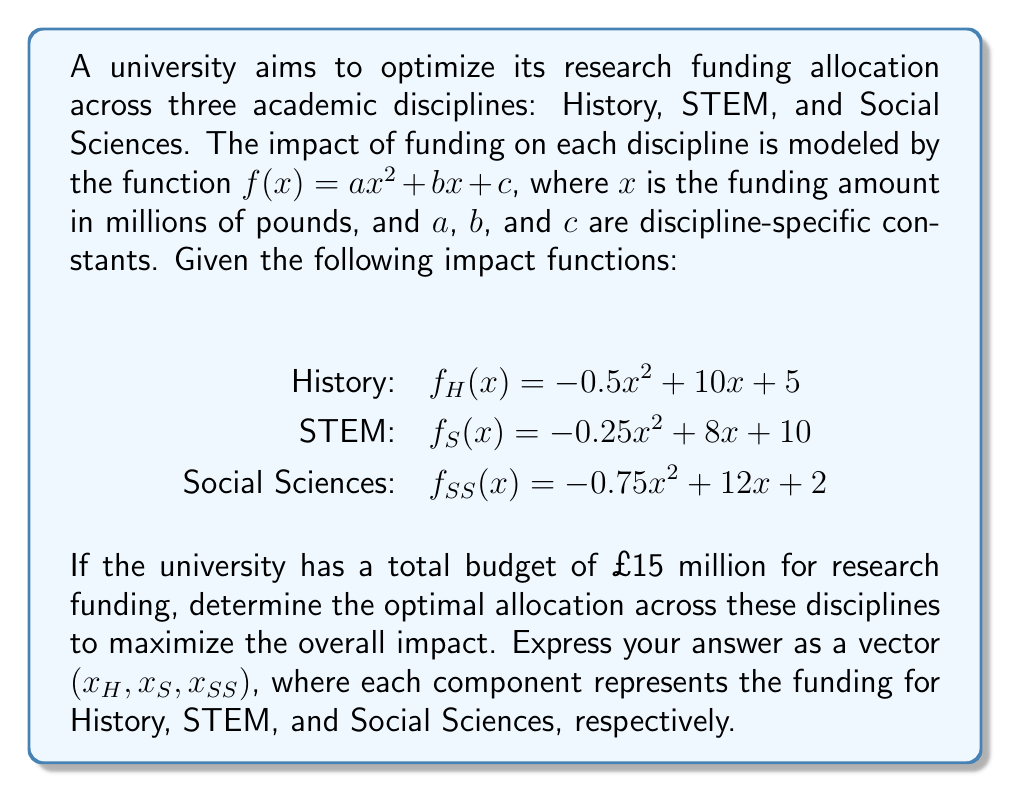Provide a solution to this math problem. To solve this optimization problem, we'll use the method of Lagrange multipliers:

1) Let's define our objective function as the sum of the impact functions:
   $$F(x_H, x_S, x_{SS}) = f_H(x_H) + f_S(x_S) + f_{SS}(x_{SS})$$

2) Our constraint is:
   $$g(x_H, x_S, x_{SS}) = x_H + x_S + x_{SS} - 15 = 0$$

3) We form the Lagrangian:
   $$L(x_H, x_S, x_{SS}, \lambda) = F(x_H, x_S, x_{SS}) - \lambda g(x_H, x_S, x_{SS})$$

4) We take partial derivatives and set them to zero:
   $$\frac{\partial L}{\partial x_H} = -x_H + 10 - \lambda = 0$$
   $$\frac{\partial L}{\partial x_S} = -0.5x_S + 8 - \lambda = 0$$
   $$\frac{\partial L}{\partial x_{SS}} = -1.5x_{SS} + 12 - \lambda = 0$$
   $$\frac{\partial L}{\partial \lambda} = x_H + x_S + x_{SS} - 15 = 0$$

5) From these equations, we can derive:
   $$x_H = 10 - \lambda$$
   $$x_S = 16 - 2\lambda$$
   $$x_{SS} = 8 - \frac{2}{3}\lambda$$

6) Substituting these into the constraint equation:
   $$(10 - \lambda) + (16 - 2\lambda) + (8 - \frac{2}{3}\lambda) = 15$$

7) Solving for $\lambda$:
   $$34 - \frac{11}{3}\lambda = 15$$
   $$\frac{11}{3}\lambda = 19$$
   $$\lambda = \frac{57}{11}$$

8) We can now solve for $x_H$, $x_S$, and $x_{SS}$:
   $$x_H = 10 - \frac{57}{11} = \frac{53}{11} \approx 4.82$$
   $$x_S = 16 - 2(\frac{57}{11}) = \frac{62}{11} \approx 5.64$$
   $$x_{SS} = 8 - \frac{2}{3}(\frac{57}{11}) = \frac{50}{11} \approx 4.55$$

Therefore, the optimal allocation is approximately (4.82, 5.64, 4.55) million pounds for History, STEM, and Social Sciences, respectively.
Answer: $(\frac{53}{11}, \frac{62}{11}, \frac{50}{11})$ 